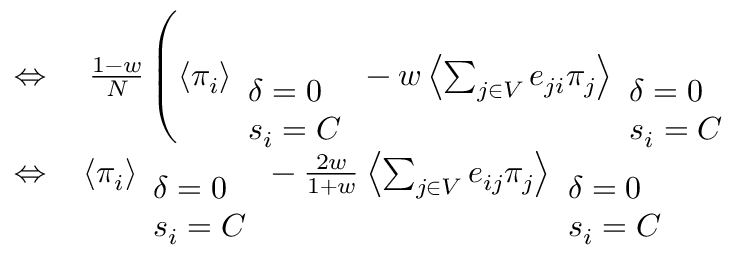Convert formula to latex. <formula><loc_0><loc_0><loc_500><loc_500>\begin{array} { r l } { \Leftrightarrow } & \frac { 1 - w } { N } \left ( \left \langle \pi _ { i } \right \rangle _ { \begin{array} { l } { \delta = 0 } \\ { s _ { i } = C } \end{array} } - w \left \langle \sum _ { j \in V } e _ { j i } \pi _ { j } \right \rangle _ { \begin{array} { l } { \delta = 0 } \\ { s _ { i } = C } \end{array} } } \\ { \Leftrightarrow } & \left \langle \pi _ { i } \right \rangle _ { \begin{array} { l } { \delta = 0 } \\ { s _ { i } = C } \end{array} } - \frac { 2 w } { 1 + w } \left \langle \sum _ { j \in V } e _ { i j } \pi _ { j } \right \rangle _ { \begin{array} { l } { \delta = 0 } \\ { s _ { i } = C } \end{array} } } \end{array}</formula> 